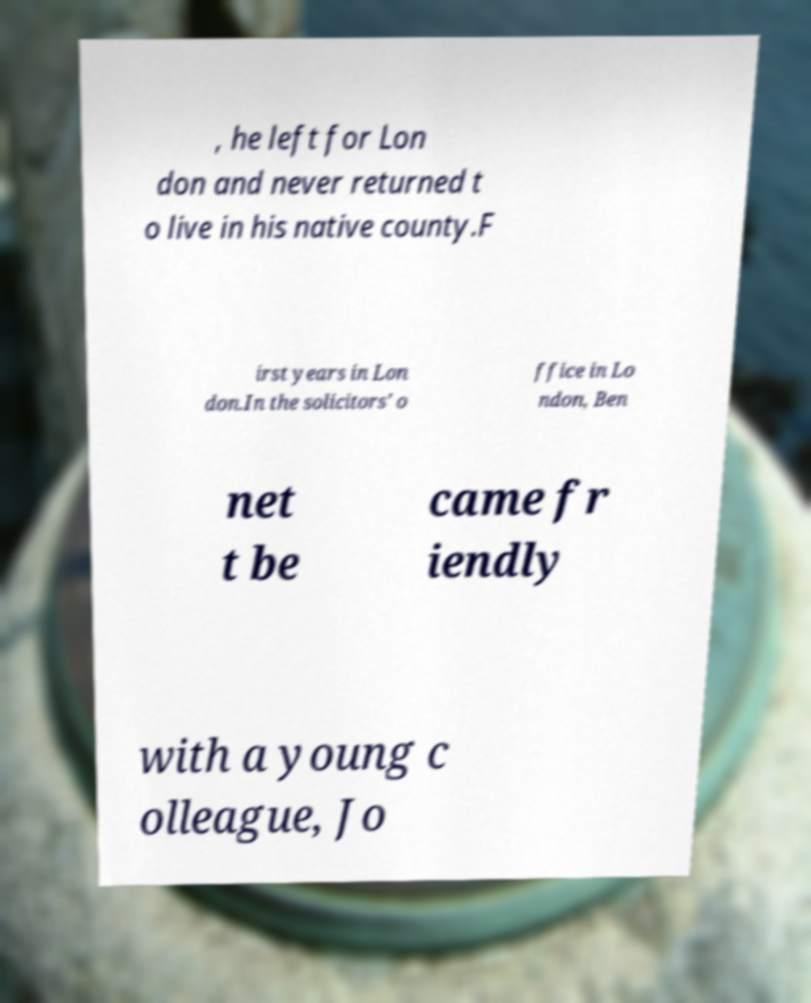What messages or text are displayed in this image? I need them in a readable, typed format. , he left for Lon don and never returned t o live in his native county.F irst years in Lon don.In the solicitors' o ffice in Lo ndon, Ben net t be came fr iendly with a young c olleague, Jo 